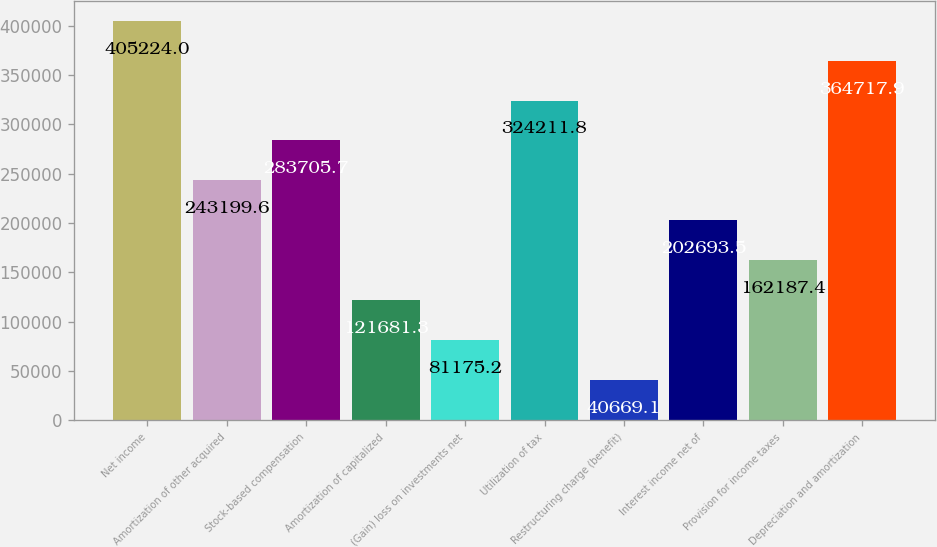<chart> <loc_0><loc_0><loc_500><loc_500><bar_chart><fcel>Net income<fcel>Amortization of other acquired<fcel>Stock-based compensation<fcel>Amortization of capitalized<fcel>(Gain) loss on investments net<fcel>Utilization of tax<fcel>Restructuring charge (benefit)<fcel>Interest income net of<fcel>Provision for income taxes<fcel>Depreciation and amortization<nl><fcel>405224<fcel>243200<fcel>283706<fcel>121681<fcel>81175.2<fcel>324212<fcel>40669.1<fcel>202694<fcel>162187<fcel>364718<nl></chart> 